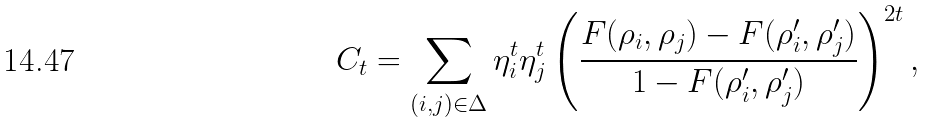Convert formula to latex. <formula><loc_0><loc_0><loc_500><loc_500>C _ { t } = \sum _ { ( i , j ) \in \Delta } \eta _ { i } ^ { t } \eta _ { j } ^ { t } \left ( \frac { F ( \rho _ { i } , \rho _ { j } ) - F ( \rho ^ { \prime } _ { i } , \rho ^ { \prime } _ { j } ) } { 1 - F ( \rho ^ { \prime } _ { i } , \rho ^ { \prime } _ { j } ) } \right ) ^ { 2 t } ,</formula> 